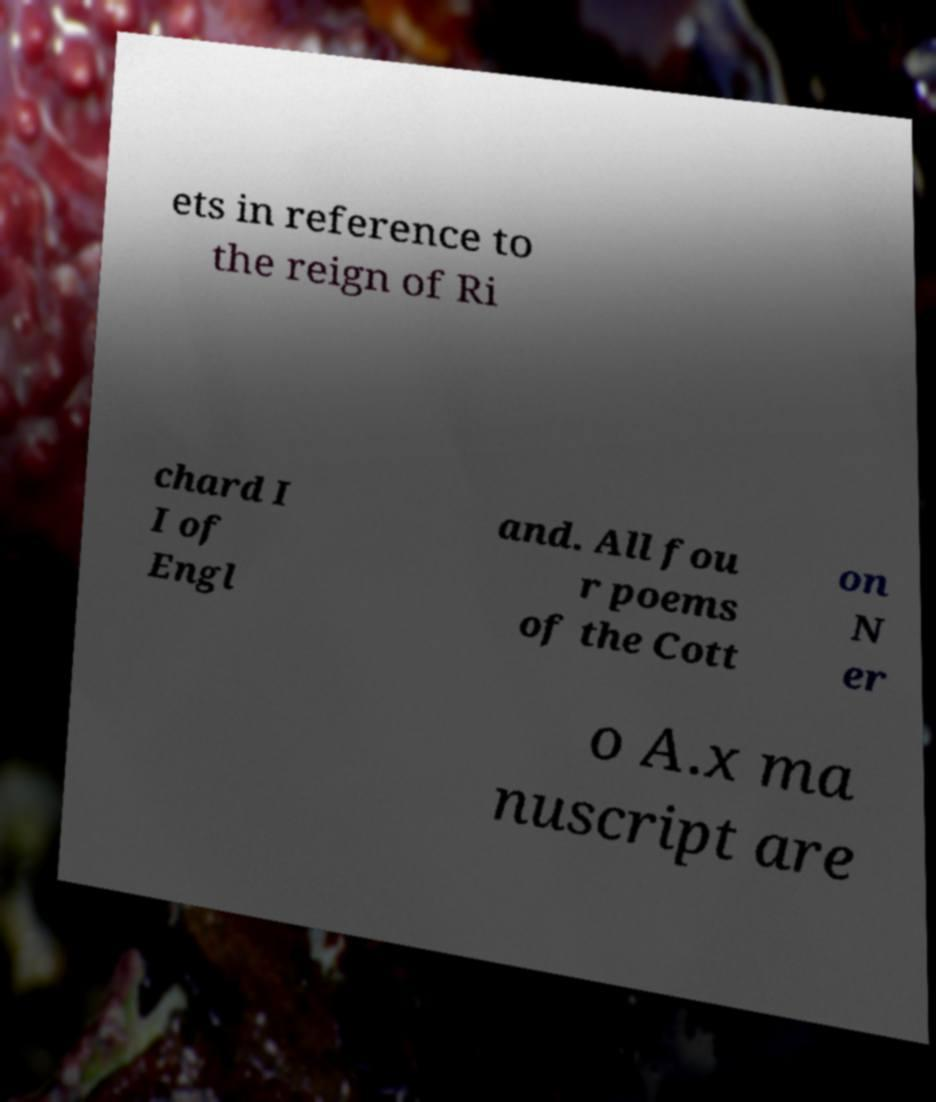Please identify and transcribe the text found in this image. ets in reference to the reign of Ri chard I I of Engl and. All fou r poems of the Cott on N er o A.x ma nuscript are 